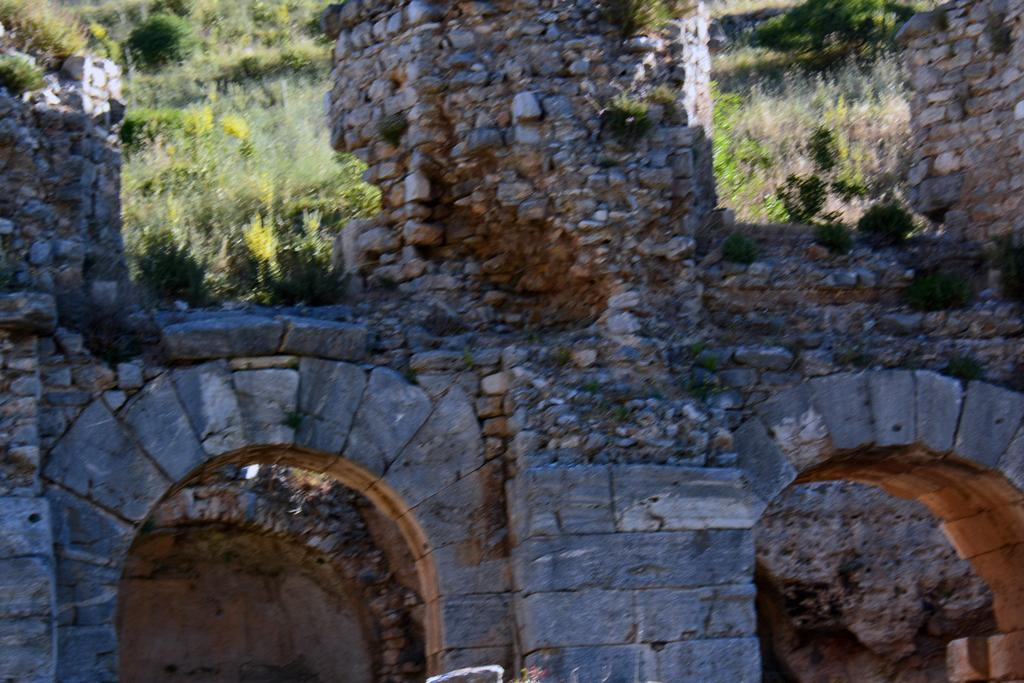What is the main structure visible in the image? There is a wall in the image. What architectural feature can be seen at the bottom of the wall? There are arches at the bottom of the wall. What type of vegetation is visible behind the wall at the top? There are trees visible behind the wall at the top. Can you hear a whistle coming from the wall in the image? There is no whistle present in the image; it is a visual representation of a wall with arches and trees in the background. 